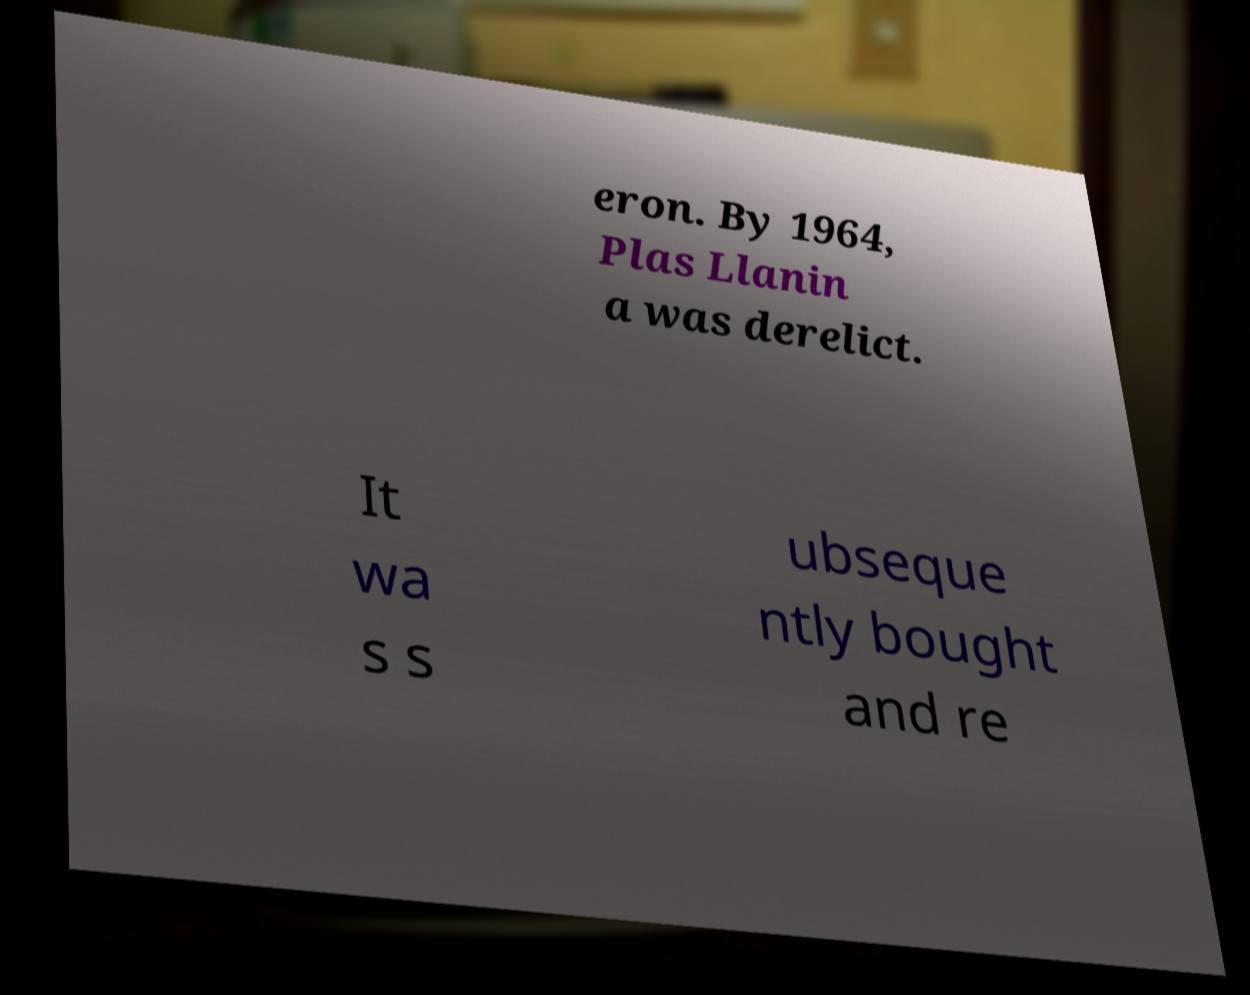There's text embedded in this image that I need extracted. Can you transcribe it verbatim? eron. By 1964, Plas Llanin a was derelict. It wa s s ubseque ntly bought and re 